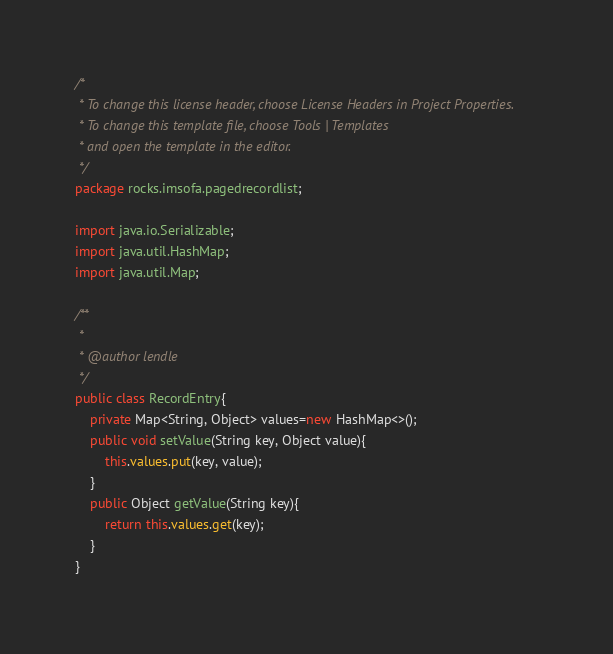<code> <loc_0><loc_0><loc_500><loc_500><_Java_>/*
 * To change this license header, choose License Headers in Project Properties.
 * To change this template file, choose Tools | Templates
 * and open the template in the editor.
 */
package rocks.imsofa.pagedrecordlist;

import java.io.Serializable;
import java.util.HashMap;
import java.util.Map;

/**
 *
 * @author lendle
 */
public class RecordEntry{
    private Map<String, Object> values=new HashMap<>();
    public void setValue(String key, Object value){
        this.values.put(key, value);
    }
    public Object getValue(String key){
        return this.values.get(key);
    }
}
</code> 